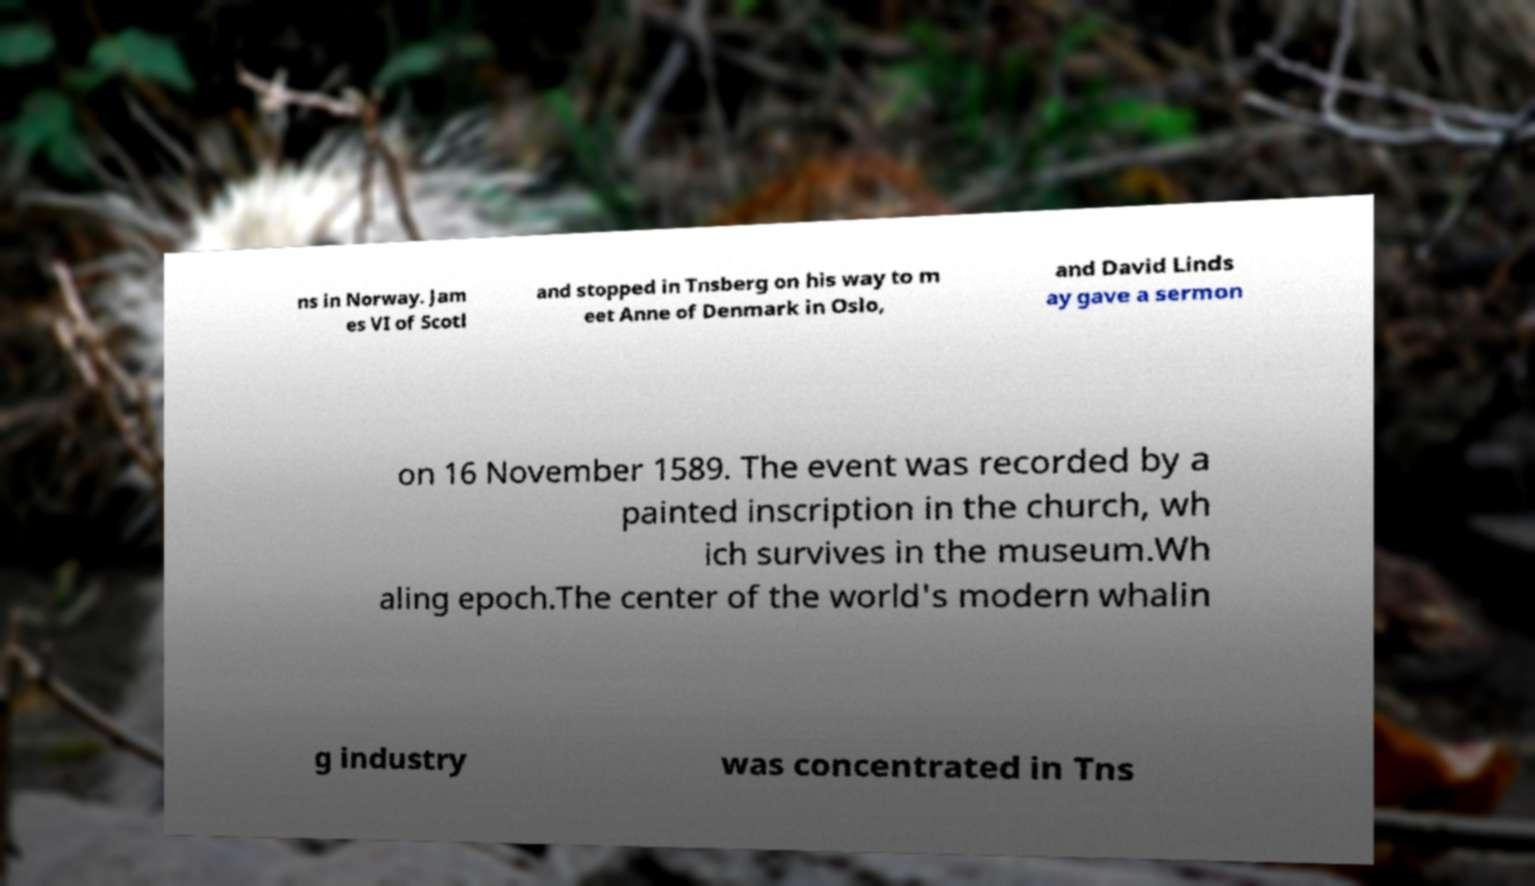Could you assist in decoding the text presented in this image and type it out clearly? ns in Norway. Jam es VI of Scotl and stopped in Tnsberg on his way to m eet Anne of Denmark in Oslo, and David Linds ay gave a sermon on 16 November 1589. The event was recorded by a painted inscription in the church, wh ich survives in the museum.Wh aling epoch.The center of the world's modern whalin g industry was concentrated in Tns 